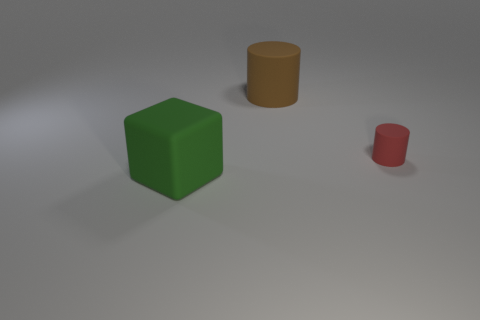Add 3 big brown things. How many objects exist? 6 Subtract all blocks. How many objects are left? 2 Subtract 1 cylinders. How many cylinders are left? 1 Subtract all purple cylinders. Subtract all gray spheres. How many cylinders are left? 2 Subtract all purple balls. How many red cylinders are left? 1 Subtract all large brown matte things. Subtract all rubber blocks. How many objects are left? 1 Add 3 small red cylinders. How many small red cylinders are left? 4 Add 2 cubes. How many cubes exist? 3 Subtract 0 yellow balls. How many objects are left? 3 